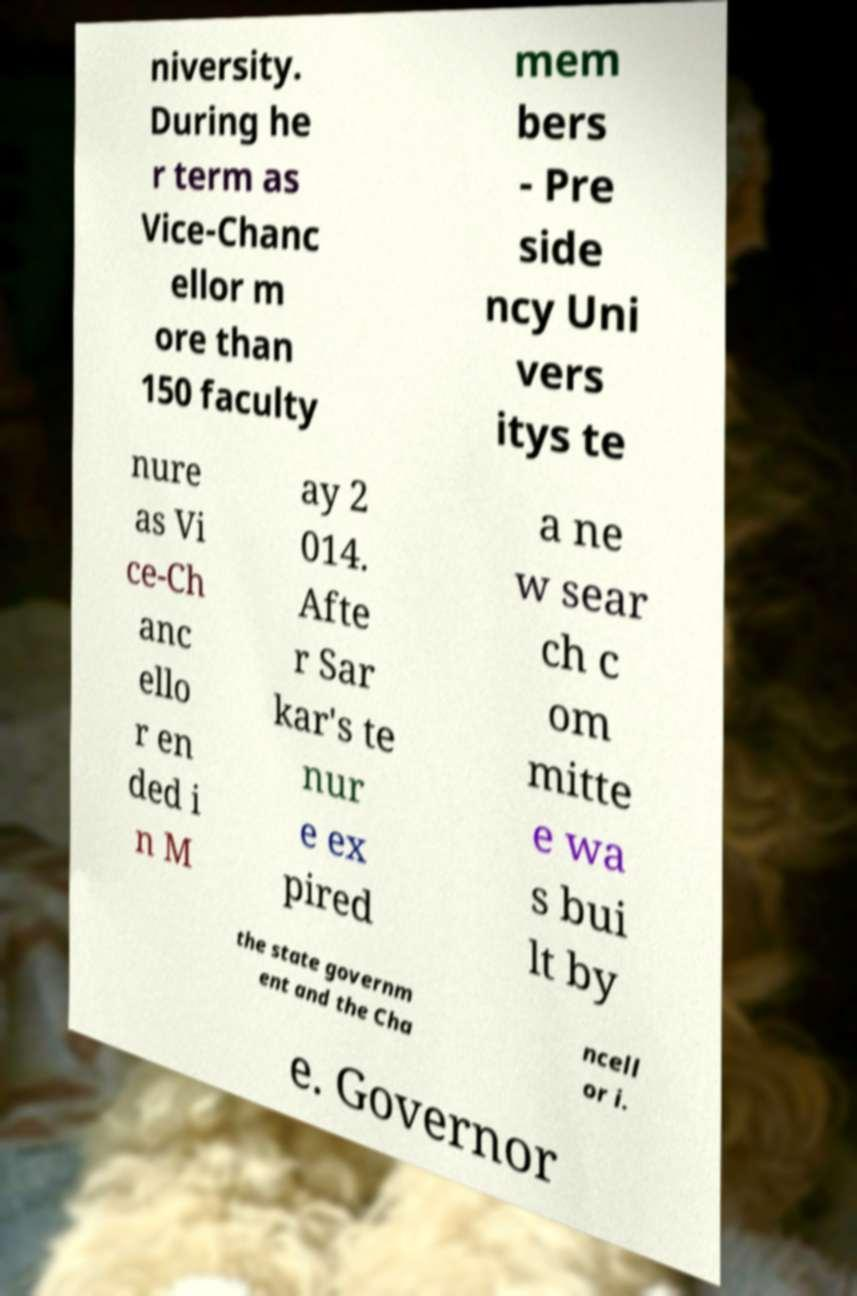For documentation purposes, I need the text within this image transcribed. Could you provide that? niversity. During he r term as Vice-Chanc ellor m ore than 150 faculty mem bers - Pre side ncy Uni vers itys te nure as Vi ce-Ch anc ello r en ded i n M ay 2 014. Afte r Sar kar's te nur e ex pired a ne w sear ch c om mitte e wa s bui lt by the state governm ent and the Cha ncell or i. e. Governor 